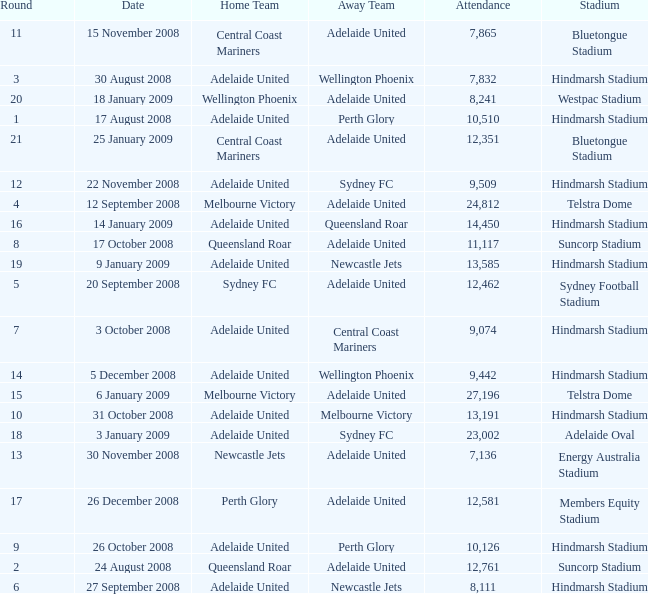In which round did 11,117 people attend the game on october 26, 2008? 9.0. 